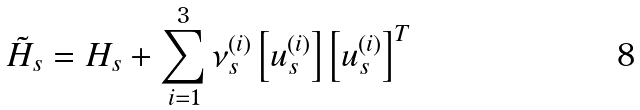<formula> <loc_0><loc_0><loc_500><loc_500>\tilde { H } _ { s } = H _ { s } + \sum _ { i = 1 } ^ { 3 } \nu _ { s } ^ { ( i ) } \left [ { u } _ { s } ^ { ( i ) } \right ] \left [ { u } _ { s } ^ { ( i ) } \right ] ^ { T }</formula> 